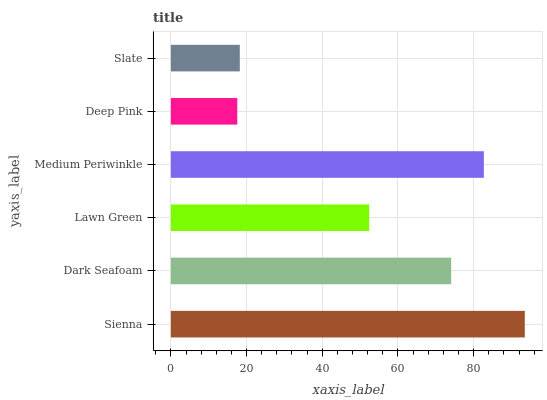Is Deep Pink the minimum?
Answer yes or no. Yes. Is Sienna the maximum?
Answer yes or no. Yes. Is Dark Seafoam the minimum?
Answer yes or no. No. Is Dark Seafoam the maximum?
Answer yes or no. No. Is Sienna greater than Dark Seafoam?
Answer yes or no. Yes. Is Dark Seafoam less than Sienna?
Answer yes or no. Yes. Is Dark Seafoam greater than Sienna?
Answer yes or no. No. Is Sienna less than Dark Seafoam?
Answer yes or no. No. Is Dark Seafoam the high median?
Answer yes or no. Yes. Is Lawn Green the low median?
Answer yes or no. Yes. Is Sienna the high median?
Answer yes or no. No. Is Slate the low median?
Answer yes or no. No. 